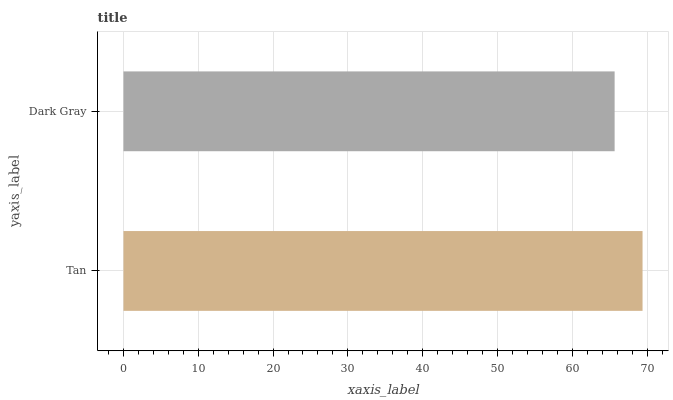Is Dark Gray the minimum?
Answer yes or no. Yes. Is Tan the maximum?
Answer yes or no. Yes. Is Dark Gray the maximum?
Answer yes or no. No. Is Tan greater than Dark Gray?
Answer yes or no. Yes. Is Dark Gray less than Tan?
Answer yes or no. Yes. Is Dark Gray greater than Tan?
Answer yes or no. No. Is Tan less than Dark Gray?
Answer yes or no. No. Is Tan the high median?
Answer yes or no. Yes. Is Dark Gray the low median?
Answer yes or no. Yes. Is Dark Gray the high median?
Answer yes or no. No. Is Tan the low median?
Answer yes or no. No. 